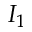<formula> <loc_0><loc_0><loc_500><loc_500>I _ { 1 }</formula> 